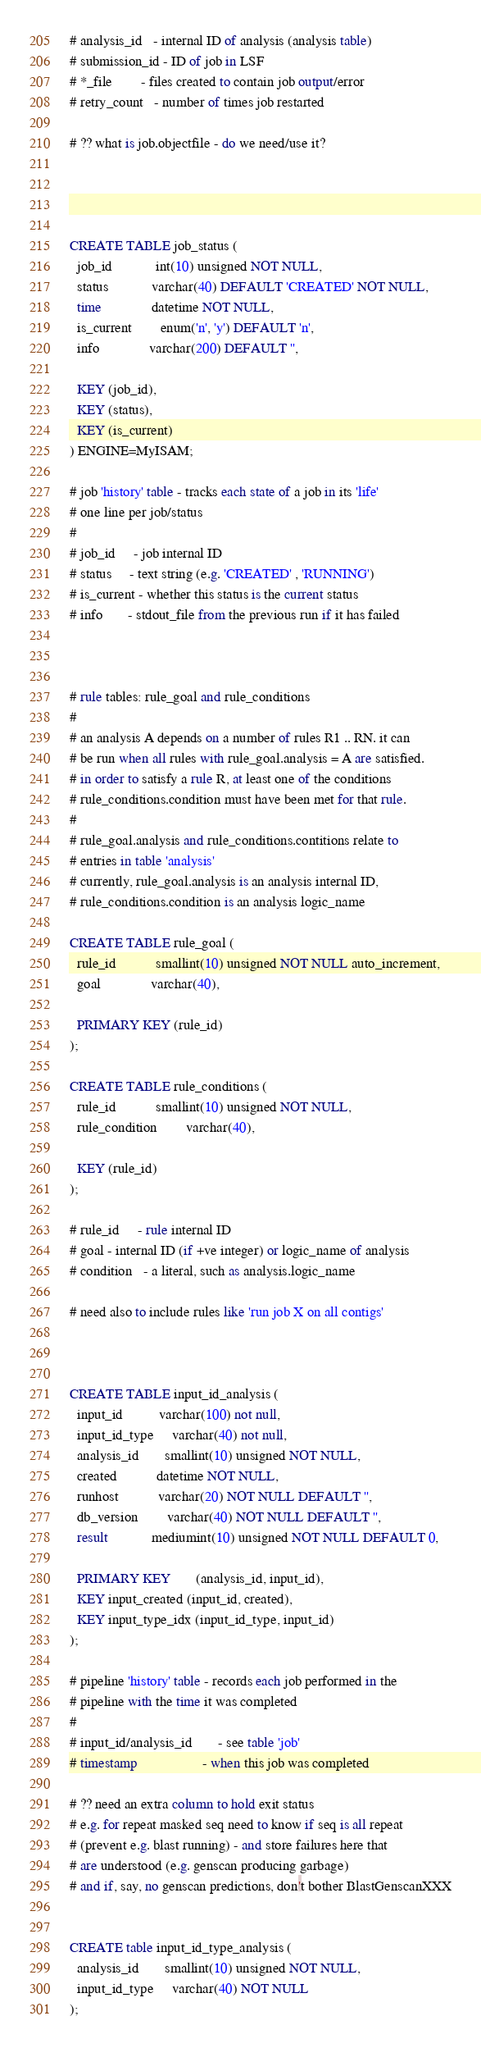<code> <loc_0><loc_0><loc_500><loc_500><_SQL_># analysis_id   - internal ID of analysis (analysis table)
# submission_id - ID of job in LSF
# *_file        - files created to contain job output/error
# retry_count   - number of times job restarted

# ?? what is job.objectfile - do we need/use it?




CREATE TABLE job_status (
  job_id            int(10) unsigned NOT NULL,
  status            varchar(40) DEFAULT 'CREATED' NOT NULL,
  time              datetime NOT NULL,
  is_current        enum('n', 'y') DEFAULT 'n',
  info              varchar(200) DEFAULT '',

  KEY (job_id),
  KEY (status),
  KEY (is_current)
) ENGINE=MyISAM;

# job 'history' table - tracks each state of a job in its 'life'
# one line per job/status
#
# job_id     - job internal ID
# status     - text string (e.g. 'CREATED' , 'RUNNING')
# is_current - whether this status is the current status
# info       - stdout_file from the previous run if it has failed



# rule tables: rule_goal and rule_conditions
#
# an analysis A depends on a number of rules R1 .. RN. it can
# be run when all rules with rule_goal.analysis = A are satisfied.
# in order to satisfy a rule R, at least one of the conditions
# rule_conditions.condition must have been met for that rule.
#
# rule_goal.analysis and rule_conditions.contitions relate to
# entries in table 'analysis'
# currently, rule_goal.analysis is an analysis internal ID,
# rule_conditions.condition is an analysis logic_name

CREATE TABLE rule_goal (
  rule_id           smallint(10) unsigned NOT NULL auto_increment,
  goal              varchar(40),

  PRIMARY KEY (rule_id)
);

CREATE TABLE rule_conditions (
  rule_id           smallint(10) unsigned NOT NULL,
  rule_condition        varchar(40),

  KEY (rule_id)
);

# rule_id     - rule internal ID
# goal - internal ID (if +ve integer) or logic_name of analysis
# condition   - a literal, such as analysis.logic_name

# need also to include rules like 'run job X on all contigs'



CREATE TABLE input_id_analysis (
  input_id          varchar(100) not null,
  input_id_type     varchar(40) not null,
  analysis_id       smallint(10) unsigned NOT NULL,
  created           datetime NOT NULL,
  runhost           varchar(20) NOT NULL DEFAULT '',
  db_version        varchar(40) NOT NULL DEFAULT '',
  result            mediumint(10) unsigned NOT NULL DEFAULT 0,

  PRIMARY KEY       (analysis_id, input_id),
  KEY input_created (input_id, created),
  KEY input_type_idx (input_id_type, input_id)
);

# pipeline 'history' table - records each job performed in the
# pipeline with the time it was completed
#
# input_id/analysis_id       - see table 'job'
# timestamp                  - when this job was completed

# ?? need an extra column to hold exit status
# e.g. for repeat masked seq need to know if seq is all repeat
# (prevent e.g. blast running) - and store failures here that
# are understood (e.g. genscan producing garbage)
# and if, say, no genscan predictions, don't bother BlastGenscanXXX


CREATE table input_id_type_analysis (
  analysis_id       smallint(10) unsigned NOT NULL,
  input_id_type     varchar(40) NOT NULL
);
</code> 